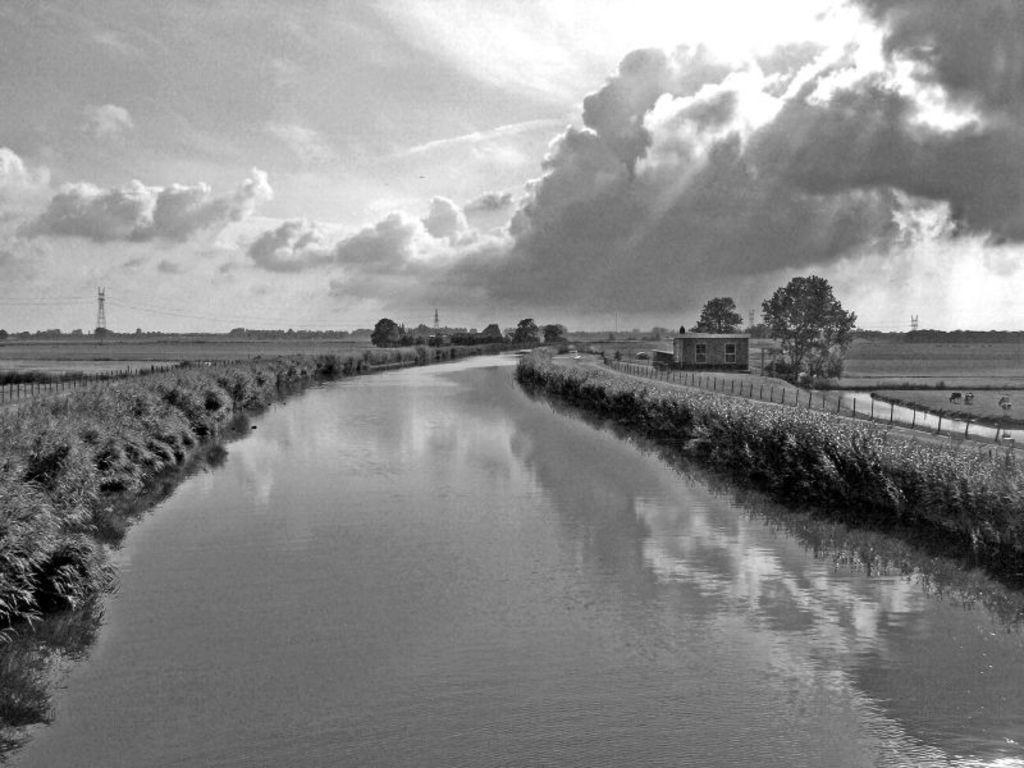In one or two sentences, can you explain what this image depicts? This is a black and white image. In this image there is water. On the sides there are plants and trees. Also there is shed with windows. In the background there is sky with clouds. Also there are towers. 